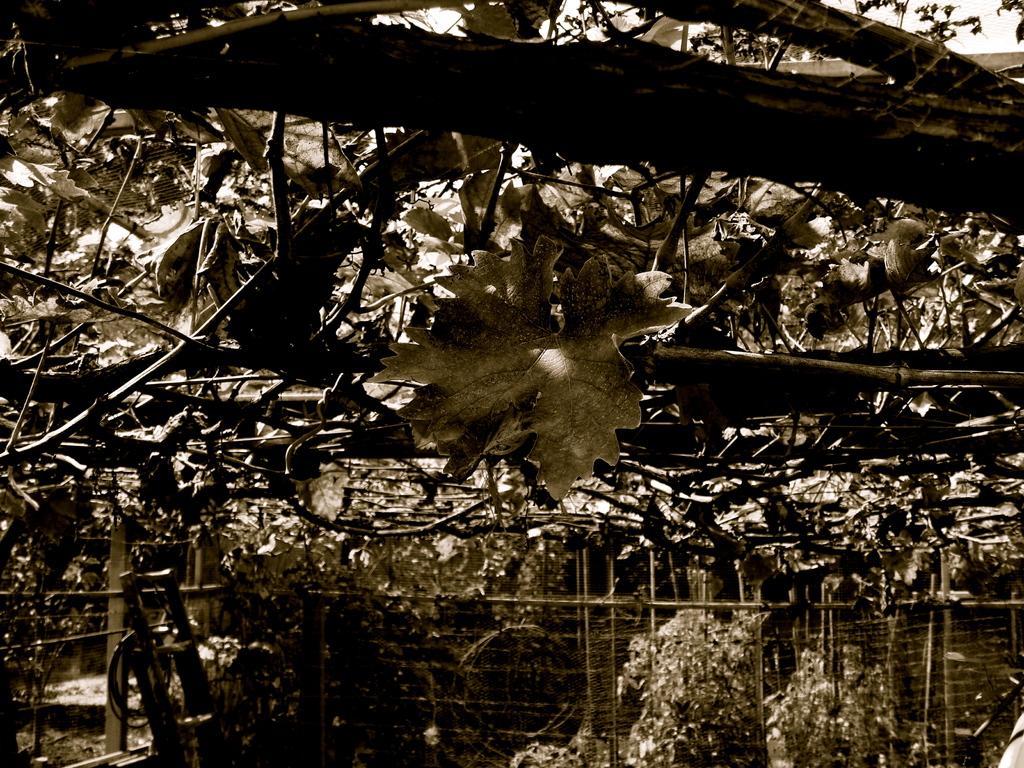Could you give a brief overview of what you see in this image? In this image there are trees, garden plants, a small ladder and a fence. 